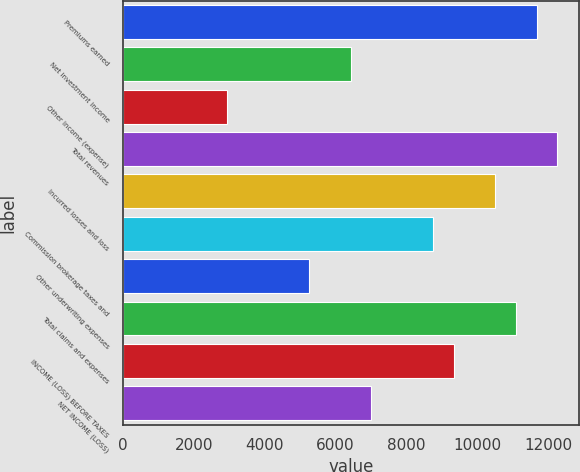Convert chart. <chart><loc_0><loc_0><loc_500><loc_500><bar_chart><fcel>Premiums earned<fcel>Net investment income<fcel>Other income (expense)<fcel>Total revenues<fcel>Incurred losses and loss<fcel>Commission brokerage taxes and<fcel>Other underwriting expenses<fcel>Total claims and expenses<fcel>INCOME (LOSS) BEFORE TAXES<fcel>NET INCOME (LOSS)<nl><fcel>11675.5<fcel>6421.66<fcel>2919.1<fcel>12259.3<fcel>10508<fcel>8756.7<fcel>5254.14<fcel>11091.7<fcel>9340.46<fcel>7005.42<nl></chart> 